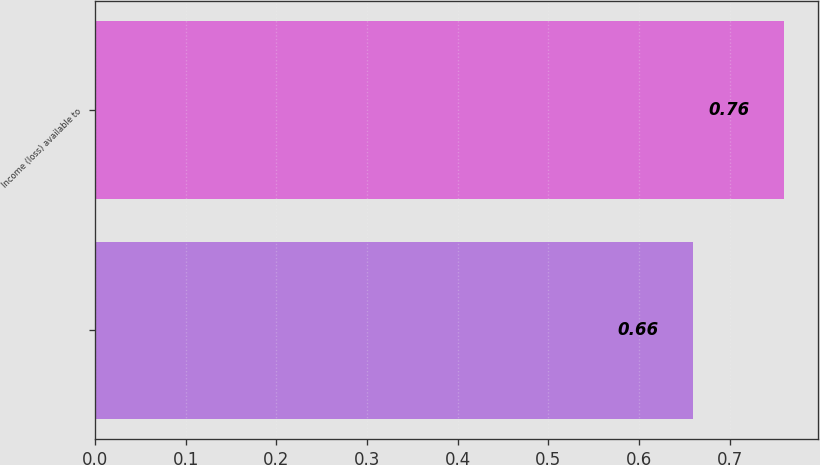<chart> <loc_0><loc_0><loc_500><loc_500><bar_chart><ecel><fcel>Income (loss) available to<nl><fcel>0.66<fcel>0.76<nl></chart> 